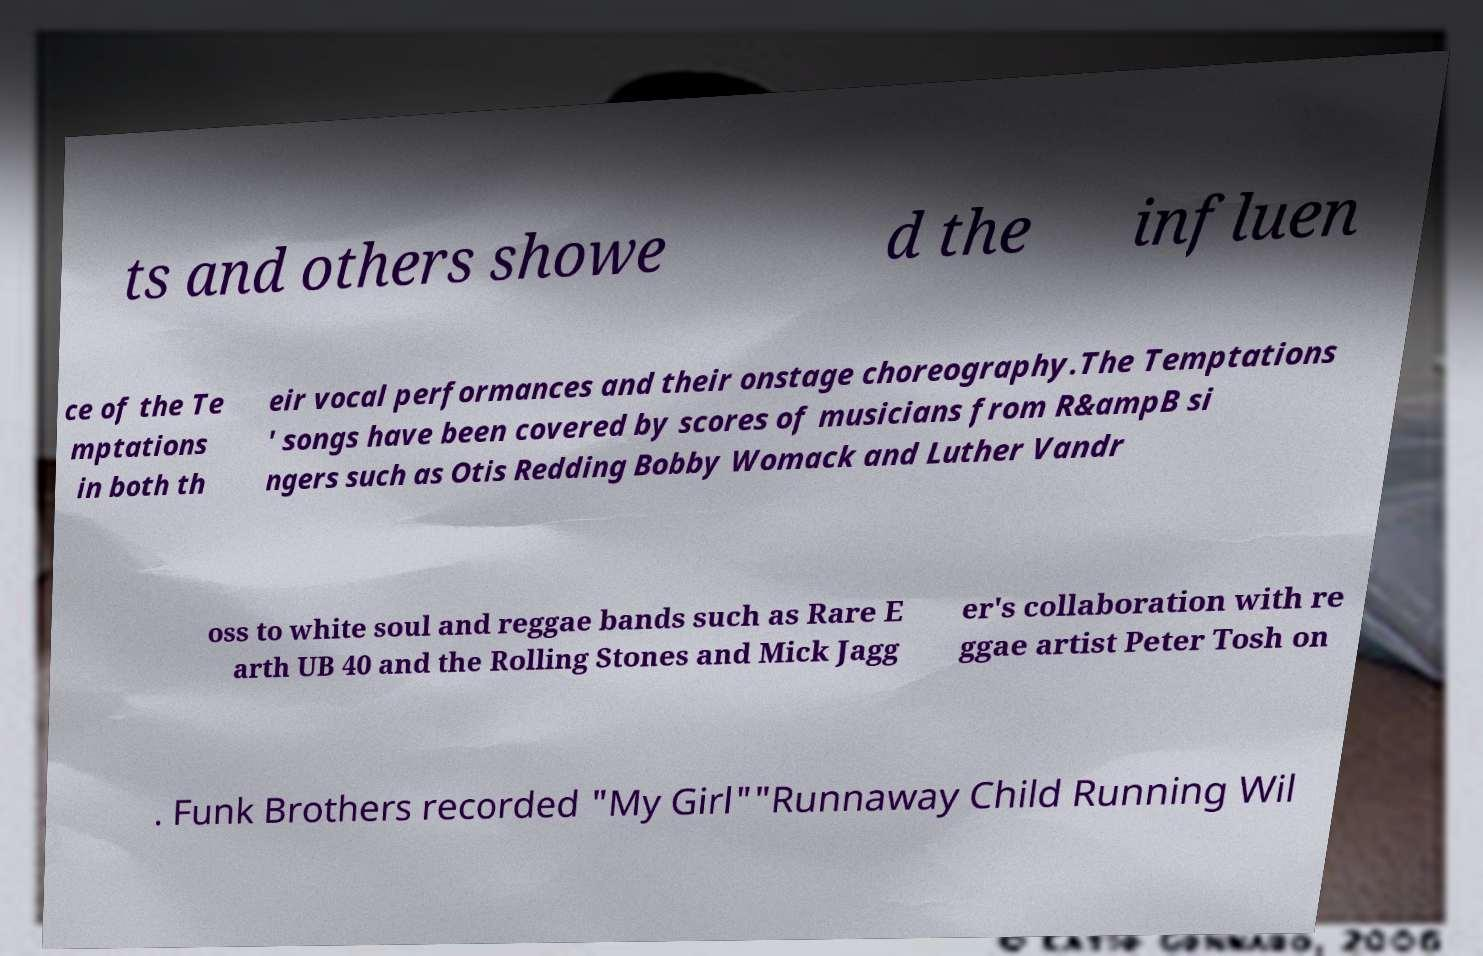Please read and relay the text visible in this image. What does it say? ts and others showe d the influen ce of the Te mptations in both th eir vocal performances and their onstage choreography.The Temptations ' songs have been covered by scores of musicians from R&ampB si ngers such as Otis Redding Bobby Womack and Luther Vandr oss to white soul and reggae bands such as Rare E arth UB 40 and the Rolling Stones and Mick Jagg er's collaboration with re ggae artist Peter Tosh on . Funk Brothers recorded "My Girl""Runnaway Child Running Wil 